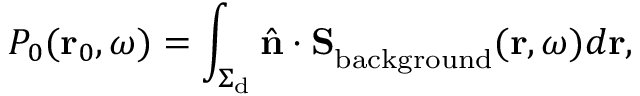Convert formula to latex. <formula><loc_0><loc_0><loc_500><loc_500>P _ { 0 } ( r _ { 0 } , \omega ) = \int _ { \Sigma _ { d } } \hat { n } \cdot { S } _ { b a c k g r o u n d } ( { r } , \omega ) d r ,</formula> 